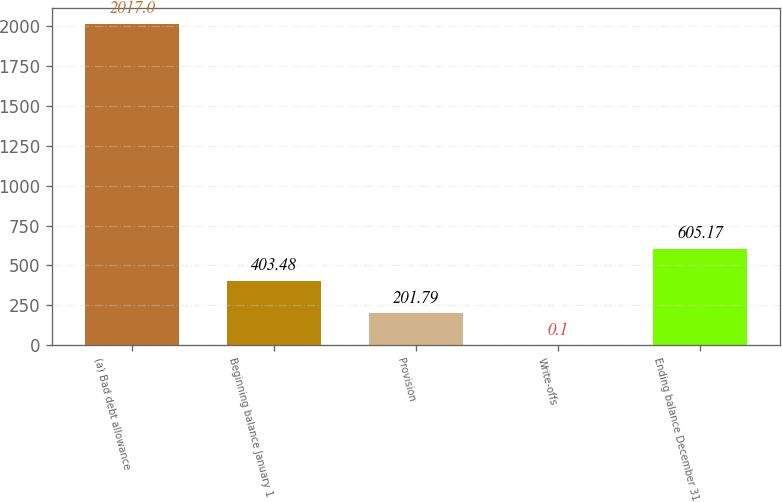Convert chart. <chart><loc_0><loc_0><loc_500><loc_500><bar_chart><fcel>(a) Bad debt allowance<fcel>Beginning balance January 1<fcel>Provision<fcel>Write-offs<fcel>Ending balance December 31<nl><fcel>2017<fcel>403.48<fcel>201.79<fcel>0.1<fcel>605.17<nl></chart> 